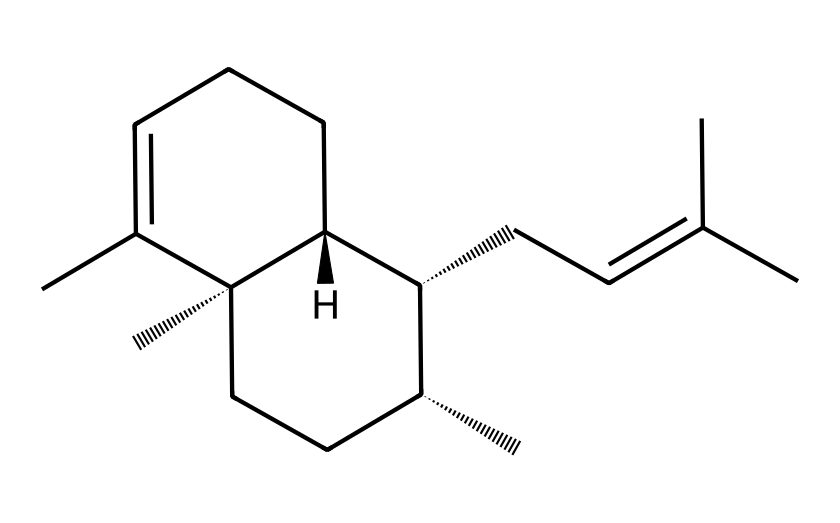What is the molecular formula of beta-caryophyllene? To determine the molecular formula, count the number of each type of atom present in the SMILES representation. From the structure, we can identify 15 carbon atoms (C) and 24 hydrogen atoms (H), leading to the formula C15H24.
Answer: C15H24 How many chiral centers does beta-caryophyllene have? A chiral center is typically characterized by a carbon atom that is attached to four different substituents. In the provided structure, there are three carbon atoms that meet this criterion, indicating three chiral centers.
Answer: 3 What type of chemical compound is beta-caryophyllene classified as? Beta-caryophyllene is categorized as a bicyclic sesquiterpene due to its structure, which includes a bicyclic framework (two fused rings) and contains 15 carbon atoms.
Answer: bicyclic sesquiterpene What is the main functional group present in beta-caryophyllene? The structure of beta-caryophyllene does not contain common functional groups such as hydroxyl or carbonyl; instead, it features aliphatic carbon chains and a double bond, classifying it primarily as a hydrocarbon without traditional functional groups.
Answer: hydrocarbon What role does beta-caryophyllene play in pain relief formulations? Beta-caryophyllene is known for its analgesic properties, as it interacts with cannabinoid receptors in the body, specifically providing pain relief when applied topically or ingested. This is relevant in topical formulations targeting pain relief.
Answer: analgesic properties How many rings are present in the structure of beta-caryophyllene? By examining the fused ring system in the structure, it is clear that beta-caryophyllene contains two interconnected rings. This is characteristic of its bicyclic structure.
Answer: 2 